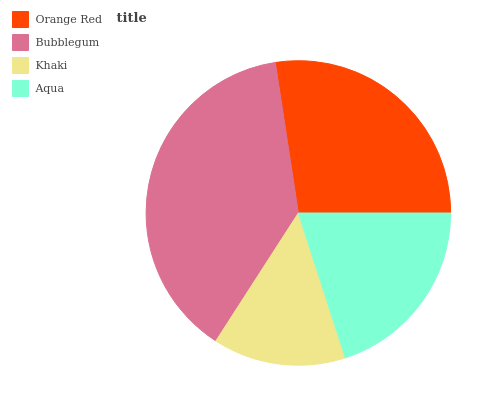Is Khaki the minimum?
Answer yes or no. Yes. Is Bubblegum the maximum?
Answer yes or no. Yes. Is Bubblegum the minimum?
Answer yes or no. No. Is Khaki the maximum?
Answer yes or no. No. Is Bubblegum greater than Khaki?
Answer yes or no. Yes. Is Khaki less than Bubblegum?
Answer yes or no. Yes. Is Khaki greater than Bubblegum?
Answer yes or no. No. Is Bubblegum less than Khaki?
Answer yes or no. No. Is Orange Red the high median?
Answer yes or no. Yes. Is Aqua the low median?
Answer yes or no. Yes. Is Khaki the high median?
Answer yes or no. No. Is Bubblegum the low median?
Answer yes or no. No. 